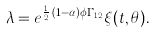Convert formula to latex. <formula><loc_0><loc_0><loc_500><loc_500>\lambda = e ^ { \frac { 1 } { 2 } \, ( 1 - \alpha ) \phi \Gamma _ { 1 2 } } \xi ( t , \theta ) .</formula> 